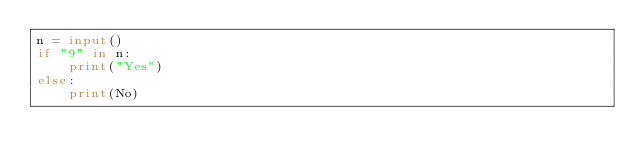Convert code to text. <code><loc_0><loc_0><loc_500><loc_500><_Python_>n = input()
if "9" in n:
    print("Yes")
else:
    print(No)</code> 